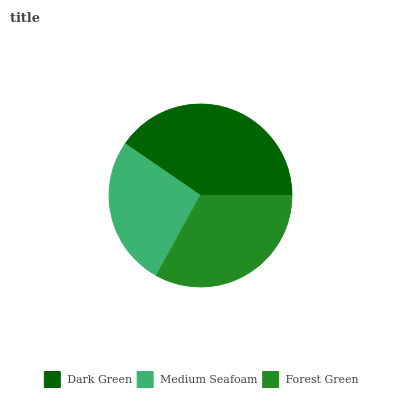Is Medium Seafoam the minimum?
Answer yes or no. Yes. Is Dark Green the maximum?
Answer yes or no. Yes. Is Forest Green the minimum?
Answer yes or no. No. Is Forest Green the maximum?
Answer yes or no. No. Is Forest Green greater than Medium Seafoam?
Answer yes or no. Yes. Is Medium Seafoam less than Forest Green?
Answer yes or no. Yes. Is Medium Seafoam greater than Forest Green?
Answer yes or no. No. Is Forest Green less than Medium Seafoam?
Answer yes or no. No. Is Forest Green the high median?
Answer yes or no. Yes. Is Forest Green the low median?
Answer yes or no. Yes. Is Dark Green the high median?
Answer yes or no. No. Is Dark Green the low median?
Answer yes or no. No. 